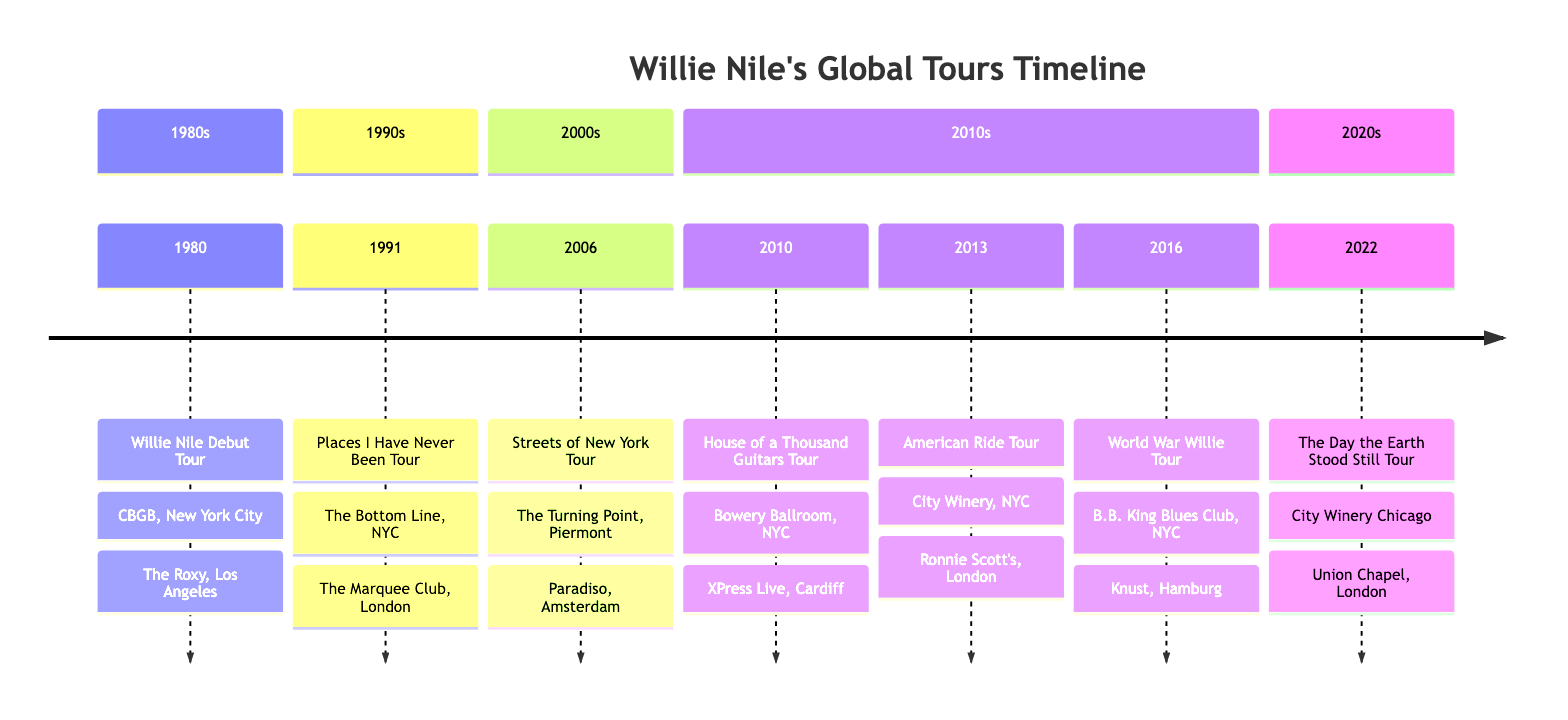What year did Willie Nile's debut tour take place? The diagram indicates the year associated with the "Willie Nile Debut Tour," which is shown as 1980.
Answer: 1980 How many tours were conducted in the 2010s? In the timeline section for the 2010s, there are three tours listed: "House of a Thousand Guitars Tour," "American Ride Tour," and "World War Willie Tour."
Answer: 3 What was the notable venue in New York City for the "Streets of New York Tour"? The diagram lists "The Turning Point" as one of the notable venues for the "Streets of New York Tour" in 2006, which is located in New York City.
Answer: The Turning Point Which tour included performances in both New York City and London? The "American Ride Tour" in 2013 includes notable venues in both New York City and London, which are mentioned in the diagram.
Answer: American Ride Tour Which venue was shared by Willie Nile for two different tours in New York City? "City Winery, New York City" appears in two different tours: "American Ride Tour" in 2013 and "The Day the Earth Stood Still Tour" in 2022.
Answer: City Winery, New York City What is the only tour listed that took place in the 2020s? The diagram shows that the only tour in the 2020s section is "The Day the Earth Stood Still Tour," which took place in 2022.
Answer: The Day the Earth Stood Still Tour What was the notable venue in London for the "World War Willie Tour"? According to the timeline, "The 100 Club" is identified as one of the notable venues for the "World War Willie Tour" in 2016, specifically located in London.
Answer: The 100 Club From which city did the "Places I Have Never Been Tour" tour originate? The diagram indicates that the "Places I Have Never Been Tour" started with notable venues including "The Bottom Line" in New York City.
Answer: New York City How many different countries did Willie Nile perform in during his tours from 1980 to 2022? Analyzing the notable venues listed for each tour shows performances in the USA (New York City, Los Angeles, Chicago), UK (London, Cardiff), and the Netherlands (Amsterdam), as well as Germany (Hamburg), totaling 4 different countries.
Answer: 4 